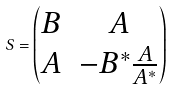Convert formula to latex. <formula><loc_0><loc_0><loc_500><loc_500>S = \begin{pmatrix} B & A \\ A & - B ^ { * } \frac { A } { A ^ { * } } \end{pmatrix}</formula> 